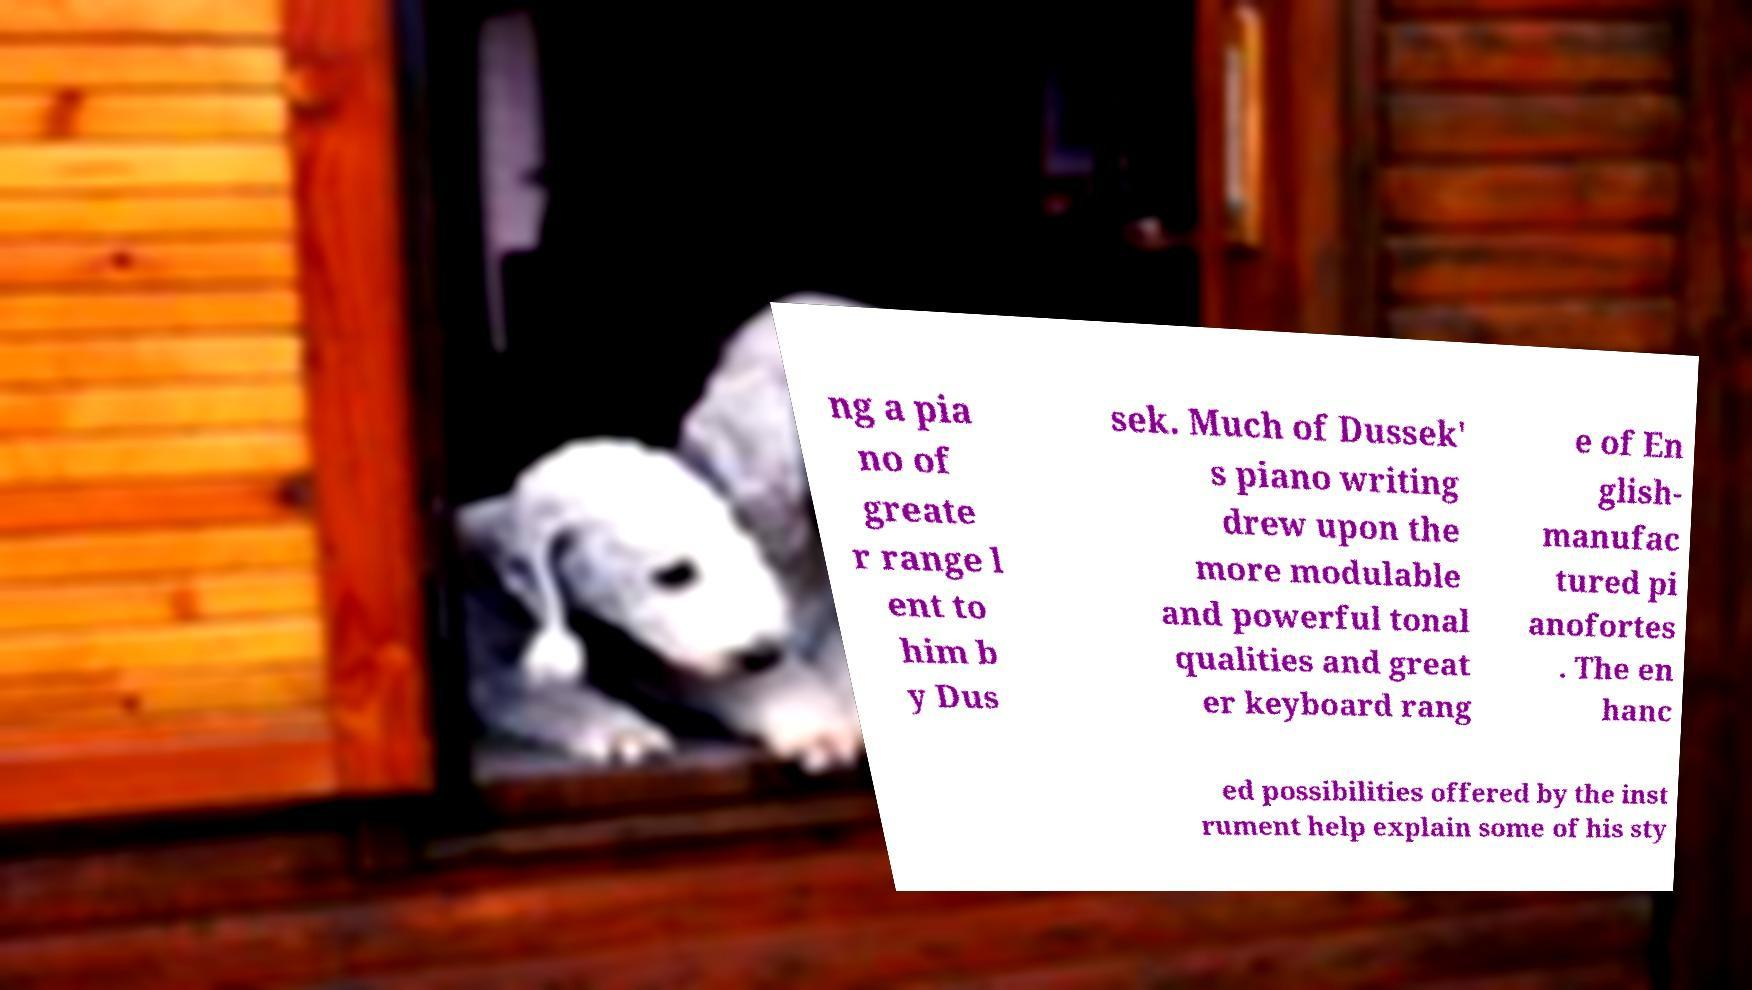Please read and relay the text visible in this image. What does it say? ng a pia no of greate r range l ent to him b y Dus sek. Much of Dussek' s piano writing drew upon the more modulable and powerful tonal qualities and great er keyboard rang e of En glish- manufac tured pi anofortes . The en hanc ed possibilities offered by the inst rument help explain some of his sty 